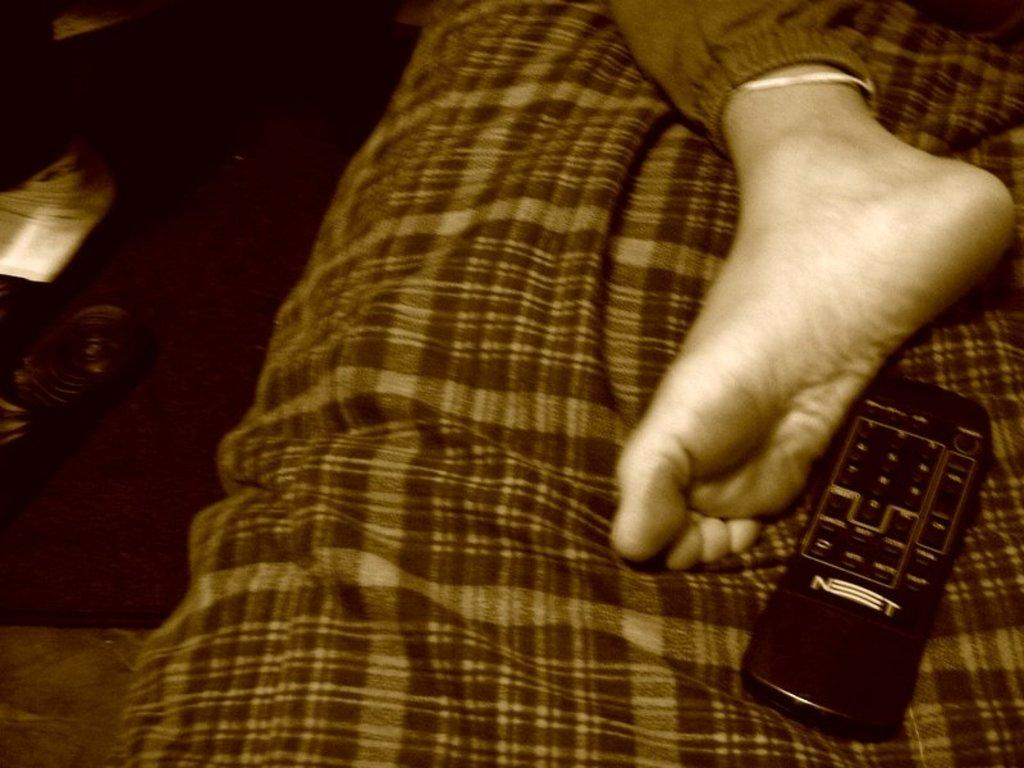Provide a one-sentence caption for the provided image. A foot is near a remote that has a word on it that starts with an N. 